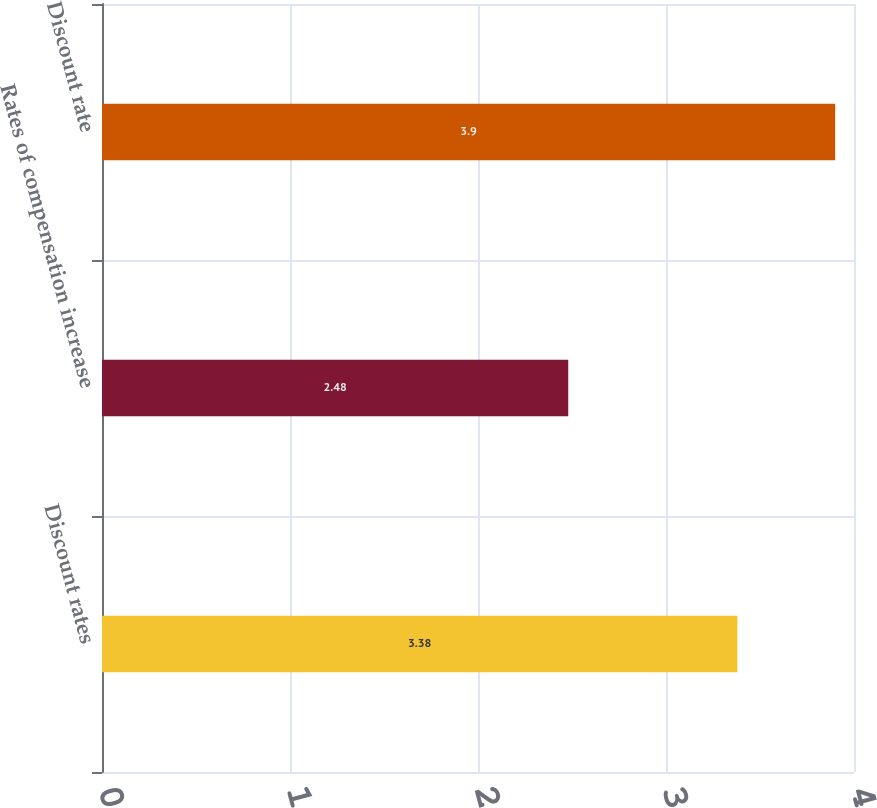Convert chart to OTSL. <chart><loc_0><loc_0><loc_500><loc_500><bar_chart><fcel>Discount rates<fcel>Rates of compensation increase<fcel>Discount rate<nl><fcel>3.38<fcel>2.48<fcel>3.9<nl></chart> 